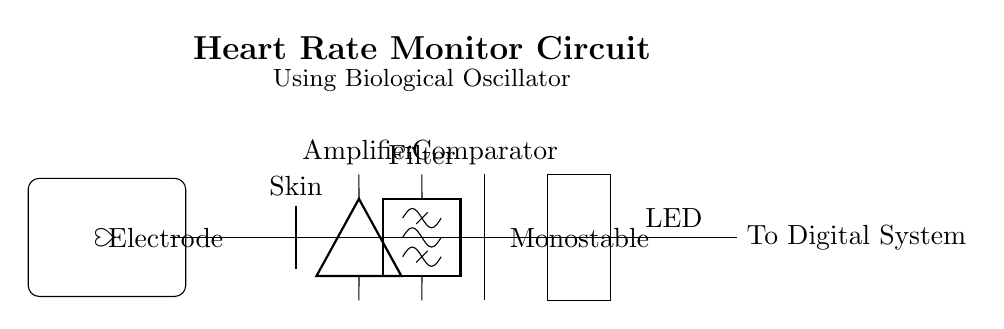What is the primary function of the amplifier in this circuit? The amplifier takes the weak biological signals from the skin and enhances their strength for further processing.
Answer: Amplification What component is responsible for filtering the frequency components? The filter component specifies which frequency ranges of the amplified signal are allowed to pass through, effectively removing unwanted noise.
Answer: Filter Which component converts the analog signal into a digital signal for processing? The comparator assesses the amplified and filtered signal to generate a digital output that can be processed by digital systems.
Answer: Comparator What is the symbol used to represent a biological oscillator in this circuit? The heart symbol, represented as a stylized heart shape, indicates the biological oscillator that generates the signal based on heart activity.
Answer: Heart What type of monostable circuit is used in this heart rate monitor design? The monostable circuit is configured to produce a single pulse output for a fixed duration in response to the triggering signal from the comparator.
Answer: Monostable How many main functional blocks are present in this circuit? The circuit contains five main functional blocks: Electrode, Amplifier, Filter, Comparator, and Monostable, contributing to monitoring the heart rate.
Answer: Five 